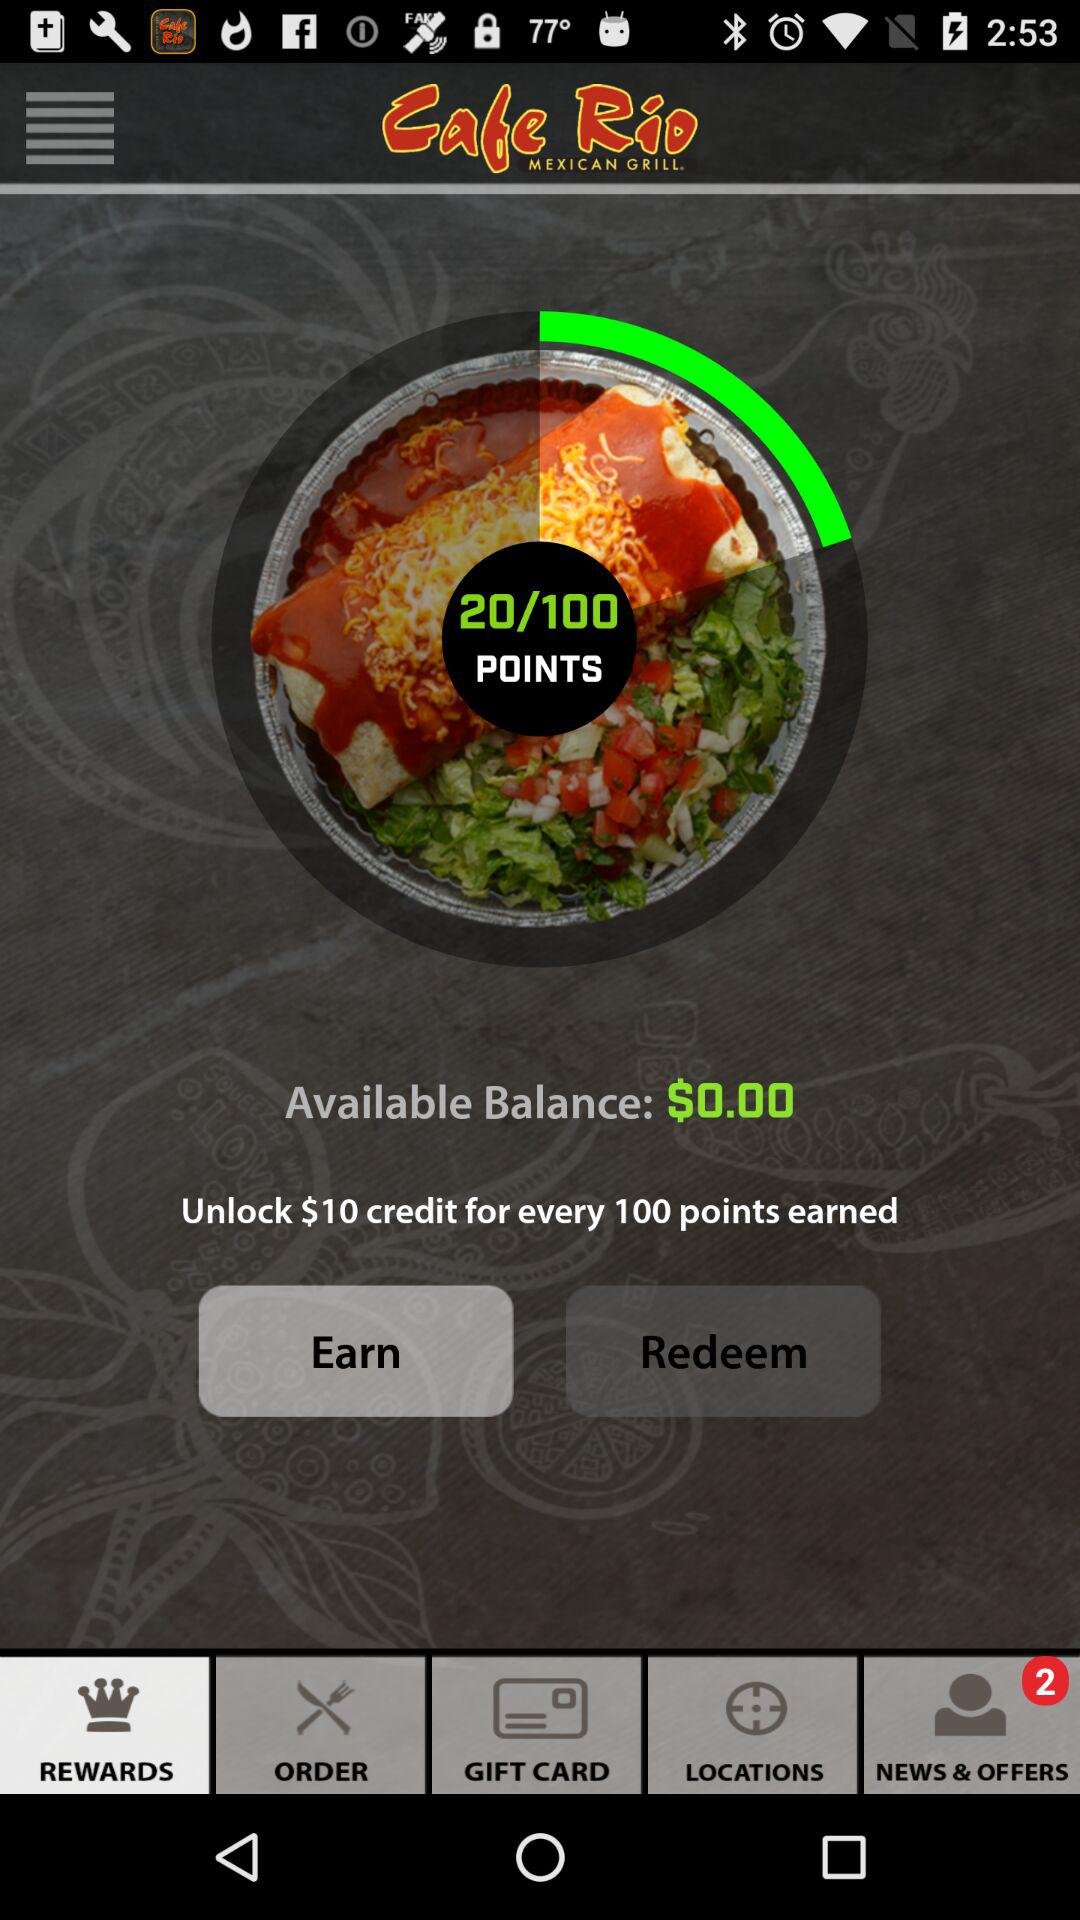How many points do I need to earn in order to redeem a $10 credit? 100 